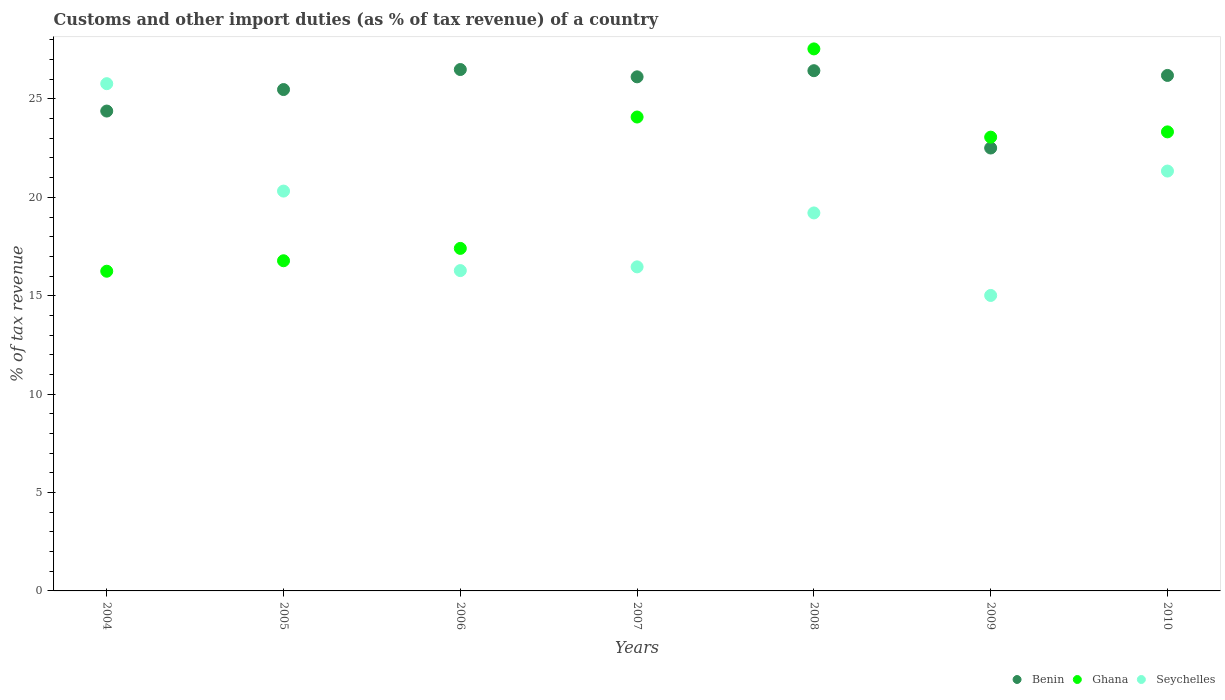How many different coloured dotlines are there?
Make the answer very short. 3. What is the percentage of tax revenue from customs in Seychelles in 2010?
Offer a very short reply. 21.34. Across all years, what is the maximum percentage of tax revenue from customs in Benin?
Your response must be concise. 26.5. Across all years, what is the minimum percentage of tax revenue from customs in Benin?
Your answer should be very brief. 22.51. What is the total percentage of tax revenue from customs in Benin in the graph?
Offer a terse response. 177.62. What is the difference between the percentage of tax revenue from customs in Benin in 2005 and that in 2010?
Provide a succinct answer. -0.72. What is the difference between the percentage of tax revenue from customs in Benin in 2008 and the percentage of tax revenue from customs in Ghana in 2007?
Your answer should be compact. 2.35. What is the average percentage of tax revenue from customs in Benin per year?
Provide a short and direct response. 25.37. In the year 2008, what is the difference between the percentage of tax revenue from customs in Benin and percentage of tax revenue from customs in Seychelles?
Keep it short and to the point. 7.23. In how many years, is the percentage of tax revenue from customs in Seychelles greater than 2 %?
Your answer should be compact. 7. What is the ratio of the percentage of tax revenue from customs in Ghana in 2004 to that in 2009?
Provide a short and direct response. 0.7. Is the difference between the percentage of tax revenue from customs in Benin in 2006 and 2010 greater than the difference between the percentage of tax revenue from customs in Seychelles in 2006 and 2010?
Make the answer very short. Yes. What is the difference between the highest and the second highest percentage of tax revenue from customs in Benin?
Your answer should be very brief. 0.06. What is the difference between the highest and the lowest percentage of tax revenue from customs in Seychelles?
Your answer should be compact. 10.76. In how many years, is the percentage of tax revenue from customs in Benin greater than the average percentage of tax revenue from customs in Benin taken over all years?
Ensure brevity in your answer.  5. Is the sum of the percentage of tax revenue from customs in Ghana in 2009 and 2010 greater than the maximum percentage of tax revenue from customs in Benin across all years?
Your answer should be very brief. Yes. Does the percentage of tax revenue from customs in Ghana monotonically increase over the years?
Offer a terse response. No. Is the percentage of tax revenue from customs in Ghana strictly greater than the percentage of tax revenue from customs in Benin over the years?
Make the answer very short. No. Is the percentage of tax revenue from customs in Benin strictly less than the percentage of tax revenue from customs in Seychelles over the years?
Ensure brevity in your answer.  No. What is the difference between two consecutive major ticks on the Y-axis?
Your response must be concise. 5. Are the values on the major ticks of Y-axis written in scientific E-notation?
Your answer should be very brief. No. Does the graph contain grids?
Give a very brief answer. No. How many legend labels are there?
Give a very brief answer. 3. How are the legend labels stacked?
Your answer should be compact. Horizontal. What is the title of the graph?
Ensure brevity in your answer.  Customs and other import duties (as % of tax revenue) of a country. What is the label or title of the Y-axis?
Provide a succinct answer. % of tax revenue. What is the % of tax revenue of Benin in 2004?
Your response must be concise. 24.38. What is the % of tax revenue in Ghana in 2004?
Your answer should be very brief. 16.25. What is the % of tax revenue of Seychelles in 2004?
Your answer should be compact. 25.78. What is the % of tax revenue in Benin in 2005?
Your answer should be compact. 25.48. What is the % of tax revenue in Ghana in 2005?
Ensure brevity in your answer.  16.78. What is the % of tax revenue in Seychelles in 2005?
Ensure brevity in your answer.  20.32. What is the % of tax revenue in Benin in 2006?
Provide a succinct answer. 26.5. What is the % of tax revenue of Ghana in 2006?
Keep it short and to the point. 17.41. What is the % of tax revenue in Seychelles in 2006?
Keep it short and to the point. 16.28. What is the % of tax revenue in Benin in 2007?
Offer a terse response. 26.12. What is the % of tax revenue of Ghana in 2007?
Provide a short and direct response. 24.08. What is the % of tax revenue in Seychelles in 2007?
Ensure brevity in your answer.  16.47. What is the % of tax revenue of Benin in 2008?
Your response must be concise. 26.44. What is the % of tax revenue of Ghana in 2008?
Ensure brevity in your answer.  27.54. What is the % of tax revenue in Seychelles in 2008?
Provide a succinct answer. 19.21. What is the % of tax revenue of Benin in 2009?
Ensure brevity in your answer.  22.51. What is the % of tax revenue in Ghana in 2009?
Provide a succinct answer. 23.06. What is the % of tax revenue in Seychelles in 2009?
Ensure brevity in your answer.  15.01. What is the % of tax revenue in Benin in 2010?
Provide a succinct answer. 26.19. What is the % of tax revenue in Ghana in 2010?
Keep it short and to the point. 23.33. What is the % of tax revenue of Seychelles in 2010?
Your response must be concise. 21.34. Across all years, what is the maximum % of tax revenue of Benin?
Provide a succinct answer. 26.5. Across all years, what is the maximum % of tax revenue in Ghana?
Ensure brevity in your answer.  27.54. Across all years, what is the maximum % of tax revenue in Seychelles?
Offer a very short reply. 25.78. Across all years, what is the minimum % of tax revenue in Benin?
Offer a very short reply. 22.51. Across all years, what is the minimum % of tax revenue of Ghana?
Keep it short and to the point. 16.25. Across all years, what is the minimum % of tax revenue in Seychelles?
Provide a short and direct response. 15.01. What is the total % of tax revenue of Benin in the graph?
Provide a short and direct response. 177.62. What is the total % of tax revenue in Ghana in the graph?
Give a very brief answer. 148.44. What is the total % of tax revenue in Seychelles in the graph?
Offer a terse response. 134.4. What is the difference between the % of tax revenue of Benin in 2004 and that in 2005?
Provide a succinct answer. -1.09. What is the difference between the % of tax revenue in Ghana in 2004 and that in 2005?
Your answer should be compact. -0.53. What is the difference between the % of tax revenue in Seychelles in 2004 and that in 2005?
Offer a terse response. 5.46. What is the difference between the % of tax revenue in Benin in 2004 and that in 2006?
Your answer should be very brief. -2.11. What is the difference between the % of tax revenue in Ghana in 2004 and that in 2006?
Your answer should be very brief. -1.16. What is the difference between the % of tax revenue in Seychelles in 2004 and that in 2006?
Your answer should be very brief. 9.5. What is the difference between the % of tax revenue of Benin in 2004 and that in 2007?
Offer a very short reply. -1.74. What is the difference between the % of tax revenue of Ghana in 2004 and that in 2007?
Your answer should be compact. -7.84. What is the difference between the % of tax revenue of Seychelles in 2004 and that in 2007?
Provide a succinct answer. 9.31. What is the difference between the % of tax revenue in Benin in 2004 and that in 2008?
Offer a terse response. -2.05. What is the difference between the % of tax revenue in Ghana in 2004 and that in 2008?
Make the answer very short. -11.3. What is the difference between the % of tax revenue in Seychelles in 2004 and that in 2008?
Make the answer very short. 6.57. What is the difference between the % of tax revenue in Benin in 2004 and that in 2009?
Your answer should be very brief. 1.88. What is the difference between the % of tax revenue of Ghana in 2004 and that in 2009?
Offer a very short reply. -6.81. What is the difference between the % of tax revenue of Seychelles in 2004 and that in 2009?
Keep it short and to the point. 10.76. What is the difference between the % of tax revenue of Benin in 2004 and that in 2010?
Provide a succinct answer. -1.81. What is the difference between the % of tax revenue of Ghana in 2004 and that in 2010?
Offer a terse response. -7.08. What is the difference between the % of tax revenue of Seychelles in 2004 and that in 2010?
Your response must be concise. 4.44. What is the difference between the % of tax revenue of Benin in 2005 and that in 2006?
Ensure brevity in your answer.  -1.02. What is the difference between the % of tax revenue in Ghana in 2005 and that in 2006?
Give a very brief answer. -0.63. What is the difference between the % of tax revenue in Seychelles in 2005 and that in 2006?
Offer a terse response. 4.04. What is the difference between the % of tax revenue of Benin in 2005 and that in 2007?
Offer a terse response. -0.65. What is the difference between the % of tax revenue in Ghana in 2005 and that in 2007?
Keep it short and to the point. -7.3. What is the difference between the % of tax revenue in Seychelles in 2005 and that in 2007?
Your response must be concise. 3.85. What is the difference between the % of tax revenue in Benin in 2005 and that in 2008?
Ensure brevity in your answer.  -0.96. What is the difference between the % of tax revenue in Ghana in 2005 and that in 2008?
Provide a short and direct response. -10.77. What is the difference between the % of tax revenue in Seychelles in 2005 and that in 2008?
Your answer should be compact. 1.11. What is the difference between the % of tax revenue in Benin in 2005 and that in 2009?
Give a very brief answer. 2.97. What is the difference between the % of tax revenue of Ghana in 2005 and that in 2009?
Provide a short and direct response. -6.28. What is the difference between the % of tax revenue of Seychelles in 2005 and that in 2009?
Your answer should be very brief. 5.3. What is the difference between the % of tax revenue in Benin in 2005 and that in 2010?
Your response must be concise. -0.72. What is the difference between the % of tax revenue of Ghana in 2005 and that in 2010?
Your answer should be compact. -6.55. What is the difference between the % of tax revenue of Seychelles in 2005 and that in 2010?
Provide a succinct answer. -1.02. What is the difference between the % of tax revenue of Benin in 2006 and that in 2007?
Offer a very short reply. 0.37. What is the difference between the % of tax revenue in Ghana in 2006 and that in 2007?
Your answer should be very brief. -6.68. What is the difference between the % of tax revenue in Seychelles in 2006 and that in 2007?
Provide a succinct answer. -0.19. What is the difference between the % of tax revenue of Benin in 2006 and that in 2008?
Give a very brief answer. 0.06. What is the difference between the % of tax revenue of Ghana in 2006 and that in 2008?
Your answer should be very brief. -10.14. What is the difference between the % of tax revenue of Seychelles in 2006 and that in 2008?
Ensure brevity in your answer.  -2.93. What is the difference between the % of tax revenue of Benin in 2006 and that in 2009?
Your answer should be compact. 3.99. What is the difference between the % of tax revenue in Ghana in 2006 and that in 2009?
Offer a very short reply. -5.65. What is the difference between the % of tax revenue in Seychelles in 2006 and that in 2009?
Ensure brevity in your answer.  1.26. What is the difference between the % of tax revenue in Benin in 2006 and that in 2010?
Give a very brief answer. 0.3. What is the difference between the % of tax revenue of Ghana in 2006 and that in 2010?
Ensure brevity in your answer.  -5.92. What is the difference between the % of tax revenue in Seychelles in 2006 and that in 2010?
Offer a very short reply. -5.06. What is the difference between the % of tax revenue in Benin in 2007 and that in 2008?
Your response must be concise. -0.31. What is the difference between the % of tax revenue of Ghana in 2007 and that in 2008?
Ensure brevity in your answer.  -3.46. What is the difference between the % of tax revenue of Seychelles in 2007 and that in 2008?
Ensure brevity in your answer.  -2.74. What is the difference between the % of tax revenue of Benin in 2007 and that in 2009?
Provide a short and direct response. 3.62. What is the difference between the % of tax revenue in Ghana in 2007 and that in 2009?
Your response must be concise. 1.02. What is the difference between the % of tax revenue of Seychelles in 2007 and that in 2009?
Offer a very short reply. 1.45. What is the difference between the % of tax revenue in Benin in 2007 and that in 2010?
Provide a short and direct response. -0.07. What is the difference between the % of tax revenue of Ghana in 2007 and that in 2010?
Your response must be concise. 0.76. What is the difference between the % of tax revenue in Seychelles in 2007 and that in 2010?
Your answer should be very brief. -4.87. What is the difference between the % of tax revenue of Benin in 2008 and that in 2009?
Your answer should be very brief. 3.93. What is the difference between the % of tax revenue in Ghana in 2008 and that in 2009?
Your response must be concise. 4.48. What is the difference between the % of tax revenue of Seychelles in 2008 and that in 2009?
Give a very brief answer. 4.19. What is the difference between the % of tax revenue in Benin in 2008 and that in 2010?
Your answer should be very brief. 0.24. What is the difference between the % of tax revenue of Ghana in 2008 and that in 2010?
Ensure brevity in your answer.  4.22. What is the difference between the % of tax revenue in Seychelles in 2008 and that in 2010?
Your response must be concise. -2.13. What is the difference between the % of tax revenue in Benin in 2009 and that in 2010?
Provide a short and direct response. -3.69. What is the difference between the % of tax revenue in Ghana in 2009 and that in 2010?
Offer a terse response. -0.27. What is the difference between the % of tax revenue in Seychelles in 2009 and that in 2010?
Ensure brevity in your answer.  -6.32. What is the difference between the % of tax revenue in Benin in 2004 and the % of tax revenue in Ghana in 2005?
Offer a terse response. 7.61. What is the difference between the % of tax revenue of Benin in 2004 and the % of tax revenue of Seychelles in 2005?
Offer a very short reply. 4.07. What is the difference between the % of tax revenue in Ghana in 2004 and the % of tax revenue in Seychelles in 2005?
Offer a terse response. -4.07. What is the difference between the % of tax revenue in Benin in 2004 and the % of tax revenue in Ghana in 2006?
Provide a short and direct response. 6.98. What is the difference between the % of tax revenue of Benin in 2004 and the % of tax revenue of Seychelles in 2006?
Provide a short and direct response. 8.11. What is the difference between the % of tax revenue of Ghana in 2004 and the % of tax revenue of Seychelles in 2006?
Provide a short and direct response. -0.03. What is the difference between the % of tax revenue of Benin in 2004 and the % of tax revenue of Ghana in 2007?
Your answer should be compact. 0.3. What is the difference between the % of tax revenue of Benin in 2004 and the % of tax revenue of Seychelles in 2007?
Make the answer very short. 7.92. What is the difference between the % of tax revenue in Ghana in 2004 and the % of tax revenue in Seychelles in 2007?
Offer a terse response. -0.22. What is the difference between the % of tax revenue in Benin in 2004 and the % of tax revenue in Ghana in 2008?
Your answer should be very brief. -3.16. What is the difference between the % of tax revenue of Benin in 2004 and the % of tax revenue of Seychelles in 2008?
Ensure brevity in your answer.  5.18. What is the difference between the % of tax revenue of Ghana in 2004 and the % of tax revenue of Seychelles in 2008?
Give a very brief answer. -2.96. What is the difference between the % of tax revenue in Benin in 2004 and the % of tax revenue in Ghana in 2009?
Your answer should be compact. 1.33. What is the difference between the % of tax revenue of Benin in 2004 and the % of tax revenue of Seychelles in 2009?
Ensure brevity in your answer.  9.37. What is the difference between the % of tax revenue of Ghana in 2004 and the % of tax revenue of Seychelles in 2009?
Your answer should be very brief. 1.23. What is the difference between the % of tax revenue of Benin in 2004 and the % of tax revenue of Ghana in 2010?
Make the answer very short. 1.06. What is the difference between the % of tax revenue in Benin in 2004 and the % of tax revenue in Seychelles in 2010?
Keep it short and to the point. 3.05. What is the difference between the % of tax revenue of Ghana in 2004 and the % of tax revenue of Seychelles in 2010?
Ensure brevity in your answer.  -5.09. What is the difference between the % of tax revenue of Benin in 2005 and the % of tax revenue of Ghana in 2006?
Ensure brevity in your answer.  8.07. What is the difference between the % of tax revenue of Benin in 2005 and the % of tax revenue of Seychelles in 2006?
Give a very brief answer. 9.2. What is the difference between the % of tax revenue in Ghana in 2005 and the % of tax revenue in Seychelles in 2006?
Offer a terse response. 0.5. What is the difference between the % of tax revenue of Benin in 2005 and the % of tax revenue of Ghana in 2007?
Provide a short and direct response. 1.4. What is the difference between the % of tax revenue in Benin in 2005 and the % of tax revenue in Seychelles in 2007?
Your answer should be very brief. 9.01. What is the difference between the % of tax revenue of Ghana in 2005 and the % of tax revenue of Seychelles in 2007?
Keep it short and to the point. 0.31. What is the difference between the % of tax revenue in Benin in 2005 and the % of tax revenue in Ghana in 2008?
Keep it short and to the point. -2.07. What is the difference between the % of tax revenue in Benin in 2005 and the % of tax revenue in Seychelles in 2008?
Your answer should be compact. 6.27. What is the difference between the % of tax revenue in Ghana in 2005 and the % of tax revenue in Seychelles in 2008?
Your response must be concise. -2.43. What is the difference between the % of tax revenue in Benin in 2005 and the % of tax revenue in Ghana in 2009?
Your answer should be compact. 2.42. What is the difference between the % of tax revenue of Benin in 2005 and the % of tax revenue of Seychelles in 2009?
Keep it short and to the point. 10.46. What is the difference between the % of tax revenue in Ghana in 2005 and the % of tax revenue in Seychelles in 2009?
Ensure brevity in your answer.  1.76. What is the difference between the % of tax revenue of Benin in 2005 and the % of tax revenue of Ghana in 2010?
Your response must be concise. 2.15. What is the difference between the % of tax revenue of Benin in 2005 and the % of tax revenue of Seychelles in 2010?
Offer a terse response. 4.14. What is the difference between the % of tax revenue of Ghana in 2005 and the % of tax revenue of Seychelles in 2010?
Ensure brevity in your answer.  -4.56. What is the difference between the % of tax revenue of Benin in 2006 and the % of tax revenue of Ghana in 2007?
Ensure brevity in your answer.  2.41. What is the difference between the % of tax revenue in Benin in 2006 and the % of tax revenue in Seychelles in 2007?
Your answer should be compact. 10.03. What is the difference between the % of tax revenue of Ghana in 2006 and the % of tax revenue of Seychelles in 2007?
Provide a succinct answer. 0.94. What is the difference between the % of tax revenue of Benin in 2006 and the % of tax revenue of Ghana in 2008?
Give a very brief answer. -1.05. What is the difference between the % of tax revenue of Benin in 2006 and the % of tax revenue of Seychelles in 2008?
Give a very brief answer. 7.29. What is the difference between the % of tax revenue in Ghana in 2006 and the % of tax revenue in Seychelles in 2008?
Offer a very short reply. -1.8. What is the difference between the % of tax revenue in Benin in 2006 and the % of tax revenue in Ghana in 2009?
Provide a succinct answer. 3.44. What is the difference between the % of tax revenue in Benin in 2006 and the % of tax revenue in Seychelles in 2009?
Provide a succinct answer. 11.48. What is the difference between the % of tax revenue of Ghana in 2006 and the % of tax revenue of Seychelles in 2009?
Your response must be concise. 2.39. What is the difference between the % of tax revenue in Benin in 2006 and the % of tax revenue in Ghana in 2010?
Offer a terse response. 3.17. What is the difference between the % of tax revenue in Benin in 2006 and the % of tax revenue in Seychelles in 2010?
Provide a succinct answer. 5.16. What is the difference between the % of tax revenue of Ghana in 2006 and the % of tax revenue of Seychelles in 2010?
Give a very brief answer. -3.93. What is the difference between the % of tax revenue of Benin in 2007 and the % of tax revenue of Ghana in 2008?
Offer a very short reply. -1.42. What is the difference between the % of tax revenue of Benin in 2007 and the % of tax revenue of Seychelles in 2008?
Offer a very short reply. 6.92. What is the difference between the % of tax revenue of Ghana in 2007 and the % of tax revenue of Seychelles in 2008?
Make the answer very short. 4.87. What is the difference between the % of tax revenue in Benin in 2007 and the % of tax revenue in Ghana in 2009?
Provide a short and direct response. 3.06. What is the difference between the % of tax revenue of Benin in 2007 and the % of tax revenue of Seychelles in 2009?
Keep it short and to the point. 11.11. What is the difference between the % of tax revenue of Ghana in 2007 and the % of tax revenue of Seychelles in 2009?
Offer a terse response. 9.07. What is the difference between the % of tax revenue of Benin in 2007 and the % of tax revenue of Ghana in 2010?
Offer a terse response. 2.8. What is the difference between the % of tax revenue of Benin in 2007 and the % of tax revenue of Seychelles in 2010?
Your answer should be very brief. 4.79. What is the difference between the % of tax revenue of Ghana in 2007 and the % of tax revenue of Seychelles in 2010?
Offer a very short reply. 2.75. What is the difference between the % of tax revenue in Benin in 2008 and the % of tax revenue in Ghana in 2009?
Provide a short and direct response. 3.38. What is the difference between the % of tax revenue of Benin in 2008 and the % of tax revenue of Seychelles in 2009?
Ensure brevity in your answer.  11.42. What is the difference between the % of tax revenue of Ghana in 2008 and the % of tax revenue of Seychelles in 2009?
Provide a short and direct response. 12.53. What is the difference between the % of tax revenue in Benin in 2008 and the % of tax revenue in Ghana in 2010?
Your response must be concise. 3.11. What is the difference between the % of tax revenue in Benin in 2008 and the % of tax revenue in Seychelles in 2010?
Ensure brevity in your answer.  5.1. What is the difference between the % of tax revenue in Ghana in 2008 and the % of tax revenue in Seychelles in 2010?
Your answer should be very brief. 6.21. What is the difference between the % of tax revenue in Benin in 2009 and the % of tax revenue in Ghana in 2010?
Ensure brevity in your answer.  -0.82. What is the difference between the % of tax revenue in Benin in 2009 and the % of tax revenue in Seychelles in 2010?
Make the answer very short. 1.17. What is the difference between the % of tax revenue of Ghana in 2009 and the % of tax revenue of Seychelles in 2010?
Provide a short and direct response. 1.72. What is the average % of tax revenue in Benin per year?
Your answer should be compact. 25.37. What is the average % of tax revenue of Ghana per year?
Your answer should be compact. 21.21. What is the average % of tax revenue in Seychelles per year?
Make the answer very short. 19.2. In the year 2004, what is the difference between the % of tax revenue in Benin and % of tax revenue in Ghana?
Provide a short and direct response. 8.14. In the year 2004, what is the difference between the % of tax revenue of Benin and % of tax revenue of Seychelles?
Provide a succinct answer. -1.39. In the year 2004, what is the difference between the % of tax revenue in Ghana and % of tax revenue in Seychelles?
Provide a short and direct response. -9.53. In the year 2005, what is the difference between the % of tax revenue in Benin and % of tax revenue in Ghana?
Ensure brevity in your answer.  8.7. In the year 2005, what is the difference between the % of tax revenue in Benin and % of tax revenue in Seychelles?
Keep it short and to the point. 5.16. In the year 2005, what is the difference between the % of tax revenue of Ghana and % of tax revenue of Seychelles?
Your answer should be very brief. -3.54. In the year 2006, what is the difference between the % of tax revenue of Benin and % of tax revenue of Ghana?
Provide a succinct answer. 9.09. In the year 2006, what is the difference between the % of tax revenue in Benin and % of tax revenue in Seychelles?
Your answer should be compact. 10.22. In the year 2006, what is the difference between the % of tax revenue of Ghana and % of tax revenue of Seychelles?
Make the answer very short. 1.13. In the year 2007, what is the difference between the % of tax revenue of Benin and % of tax revenue of Ghana?
Offer a terse response. 2.04. In the year 2007, what is the difference between the % of tax revenue in Benin and % of tax revenue in Seychelles?
Your response must be concise. 9.66. In the year 2007, what is the difference between the % of tax revenue in Ghana and % of tax revenue in Seychelles?
Your answer should be compact. 7.61. In the year 2008, what is the difference between the % of tax revenue in Benin and % of tax revenue in Ghana?
Ensure brevity in your answer.  -1.11. In the year 2008, what is the difference between the % of tax revenue of Benin and % of tax revenue of Seychelles?
Provide a short and direct response. 7.23. In the year 2008, what is the difference between the % of tax revenue in Ghana and % of tax revenue in Seychelles?
Offer a terse response. 8.34. In the year 2009, what is the difference between the % of tax revenue in Benin and % of tax revenue in Ghana?
Offer a very short reply. -0.55. In the year 2009, what is the difference between the % of tax revenue in Benin and % of tax revenue in Seychelles?
Provide a succinct answer. 7.49. In the year 2009, what is the difference between the % of tax revenue of Ghana and % of tax revenue of Seychelles?
Offer a terse response. 8.04. In the year 2010, what is the difference between the % of tax revenue of Benin and % of tax revenue of Ghana?
Provide a short and direct response. 2.87. In the year 2010, what is the difference between the % of tax revenue of Benin and % of tax revenue of Seychelles?
Offer a terse response. 4.86. In the year 2010, what is the difference between the % of tax revenue of Ghana and % of tax revenue of Seychelles?
Keep it short and to the point. 1.99. What is the ratio of the % of tax revenue of Benin in 2004 to that in 2005?
Offer a terse response. 0.96. What is the ratio of the % of tax revenue in Ghana in 2004 to that in 2005?
Give a very brief answer. 0.97. What is the ratio of the % of tax revenue in Seychelles in 2004 to that in 2005?
Make the answer very short. 1.27. What is the ratio of the % of tax revenue in Benin in 2004 to that in 2006?
Provide a short and direct response. 0.92. What is the ratio of the % of tax revenue of Seychelles in 2004 to that in 2006?
Provide a short and direct response. 1.58. What is the ratio of the % of tax revenue in Benin in 2004 to that in 2007?
Your answer should be compact. 0.93. What is the ratio of the % of tax revenue of Ghana in 2004 to that in 2007?
Make the answer very short. 0.67. What is the ratio of the % of tax revenue of Seychelles in 2004 to that in 2007?
Keep it short and to the point. 1.57. What is the ratio of the % of tax revenue of Benin in 2004 to that in 2008?
Make the answer very short. 0.92. What is the ratio of the % of tax revenue in Ghana in 2004 to that in 2008?
Your response must be concise. 0.59. What is the ratio of the % of tax revenue of Seychelles in 2004 to that in 2008?
Provide a short and direct response. 1.34. What is the ratio of the % of tax revenue of Benin in 2004 to that in 2009?
Ensure brevity in your answer.  1.08. What is the ratio of the % of tax revenue of Ghana in 2004 to that in 2009?
Ensure brevity in your answer.  0.7. What is the ratio of the % of tax revenue in Seychelles in 2004 to that in 2009?
Give a very brief answer. 1.72. What is the ratio of the % of tax revenue in Benin in 2004 to that in 2010?
Keep it short and to the point. 0.93. What is the ratio of the % of tax revenue of Ghana in 2004 to that in 2010?
Ensure brevity in your answer.  0.7. What is the ratio of the % of tax revenue of Seychelles in 2004 to that in 2010?
Offer a terse response. 1.21. What is the ratio of the % of tax revenue in Benin in 2005 to that in 2006?
Your response must be concise. 0.96. What is the ratio of the % of tax revenue of Ghana in 2005 to that in 2006?
Offer a terse response. 0.96. What is the ratio of the % of tax revenue of Seychelles in 2005 to that in 2006?
Offer a terse response. 1.25. What is the ratio of the % of tax revenue of Benin in 2005 to that in 2007?
Offer a very short reply. 0.98. What is the ratio of the % of tax revenue of Ghana in 2005 to that in 2007?
Ensure brevity in your answer.  0.7. What is the ratio of the % of tax revenue in Seychelles in 2005 to that in 2007?
Your answer should be very brief. 1.23. What is the ratio of the % of tax revenue of Benin in 2005 to that in 2008?
Ensure brevity in your answer.  0.96. What is the ratio of the % of tax revenue in Ghana in 2005 to that in 2008?
Offer a very short reply. 0.61. What is the ratio of the % of tax revenue in Seychelles in 2005 to that in 2008?
Your answer should be very brief. 1.06. What is the ratio of the % of tax revenue in Benin in 2005 to that in 2009?
Provide a succinct answer. 1.13. What is the ratio of the % of tax revenue of Ghana in 2005 to that in 2009?
Make the answer very short. 0.73. What is the ratio of the % of tax revenue in Seychelles in 2005 to that in 2009?
Ensure brevity in your answer.  1.35. What is the ratio of the % of tax revenue of Benin in 2005 to that in 2010?
Ensure brevity in your answer.  0.97. What is the ratio of the % of tax revenue in Ghana in 2005 to that in 2010?
Offer a very short reply. 0.72. What is the ratio of the % of tax revenue of Seychelles in 2005 to that in 2010?
Offer a terse response. 0.95. What is the ratio of the % of tax revenue in Benin in 2006 to that in 2007?
Ensure brevity in your answer.  1.01. What is the ratio of the % of tax revenue in Ghana in 2006 to that in 2007?
Offer a terse response. 0.72. What is the ratio of the % of tax revenue of Ghana in 2006 to that in 2008?
Provide a succinct answer. 0.63. What is the ratio of the % of tax revenue of Seychelles in 2006 to that in 2008?
Your answer should be very brief. 0.85. What is the ratio of the % of tax revenue of Benin in 2006 to that in 2009?
Ensure brevity in your answer.  1.18. What is the ratio of the % of tax revenue in Ghana in 2006 to that in 2009?
Keep it short and to the point. 0.75. What is the ratio of the % of tax revenue in Seychelles in 2006 to that in 2009?
Ensure brevity in your answer.  1.08. What is the ratio of the % of tax revenue of Benin in 2006 to that in 2010?
Give a very brief answer. 1.01. What is the ratio of the % of tax revenue in Ghana in 2006 to that in 2010?
Give a very brief answer. 0.75. What is the ratio of the % of tax revenue of Seychelles in 2006 to that in 2010?
Your answer should be compact. 0.76. What is the ratio of the % of tax revenue of Ghana in 2007 to that in 2008?
Offer a very short reply. 0.87. What is the ratio of the % of tax revenue in Seychelles in 2007 to that in 2008?
Provide a short and direct response. 0.86. What is the ratio of the % of tax revenue of Benin in 2007 to that in 2009?
Provide a succinct answer. 1.16. What is the ratio of the % of tax revenue of Ghana in 2007 to that in 2009?
Keep it short and to the point. 1.04. What is the ratio of the % of tax revenue of Seychelles in 2007 to that in 2009?
Offer a very short reply. 1.1. What is the ratio of the % of tax revenue in Ghana in 2007 to that in 2010?
Keep it short and to the point. 1.03. What is the ratio of the % of tax revenue of Seychelles in 2007 to that in 2010?
Keep it short and to the point. 0.77. What is the ratio of the % of tax revenue in Benin in 2008 to that in 2009?
Keep it short and to the point. 1.17. What is the ratio of the % of tax revenue in Ghana in 2008 to that in 2009?
Your response must be concise. 1.19. What is the ratio of the % of tax revenue in Seychelles in 2008 to that in 2009?
Your answer should be compact. 1.28. What is the ratio of the % of tax revenue of Benin in 2008 to that in 2010?
Give a very brief answer. 1.01. What is the ratio of the % of tax revenue in Ghana in 2008 to that in 2010?
Give a very brief answer. 1.18. What is the ratio of the % of tax revenue in Seychelles in 2008 to that in 2010?
Your response must be concise. 0.9. What is the ratio of the % of tax revenue of Benin in 2009 to that in 2010?
Offer a very short reply. 0.86. What is the ratio of the % of tax revenue in Seychelles in 2009 to that in 2010?
Provide a succinct answer. 0.7. What is the difference between the highest and the second highest % of tax revenue of Benin?
Give a very brief answer. 0.06. What is the difference between the highest and the second highest % of tax revenue in Ghana?
Keep it short and to the point. 3.46. What is the difference between the highest and the second highest % of tax revenue in Seychelles?
Your response must be concise. 4.44. What is the difference between the highest and the lowest % of tax revenue in Benin?
Your answer should be compact. 3.99. What is the difference between the highest and the lowest % of tax revenue of Ghana?
Ensure brevity in your answer.  11.3. What is the difference between the highest and the lowest % of tax revenue of Seychelles?
Ensure brevity in your answer.  10.76. 